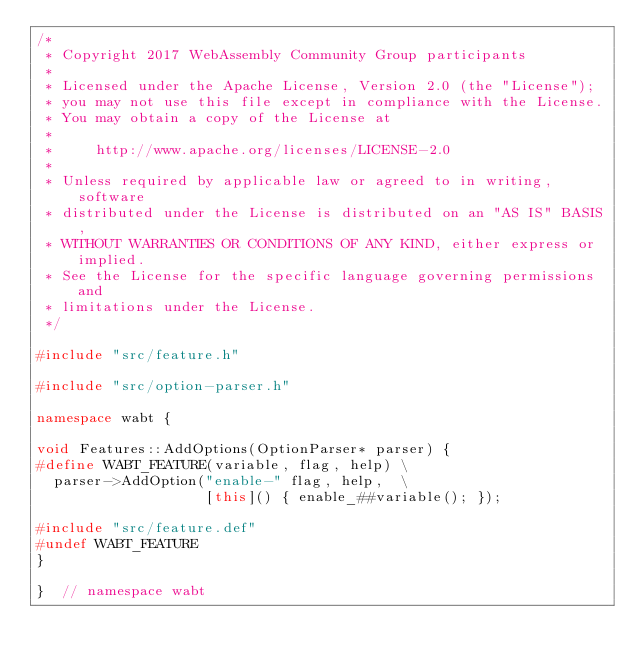<code> <loc_0><loc_0><loc_500><loc_500><_C++_>/*
 * Copyright 2017 WebAssembly Community Group participants
 *
 * Licensed under the Apache License, Version 2.0 (the "License");
 * you may not use this file except in compliance with the License.
 * You may obtain a copy of the License at
 *
 *     http://www.apache.org/licenses/LICENSE-2.0
 *
 * Unless required by applicable law or agreed to in writing, software
 * distributed under the License is distributed on an "AS IS" BASIS,
 * WITHOUT WARRANTIES OR CONDITIONS OF ANY KIND, either express or implied.
 * See the License for the specific language governing permissions and
 * limitations under the License.
 */

#include "src/feature.h"

#include "src/option-parser.h"

namespace wabt {

void Features::AddOptions(OptionParser* parser) {
#define WABT_FEATURE(variable, flag, help) \
  parser->AddOption("enable-" flag, help,  \
                    [this]() { enable_##variable(); });

#include "src/feature.def"
#undef WABT_FEATURE
}

}  // namespace wabt
</code> 